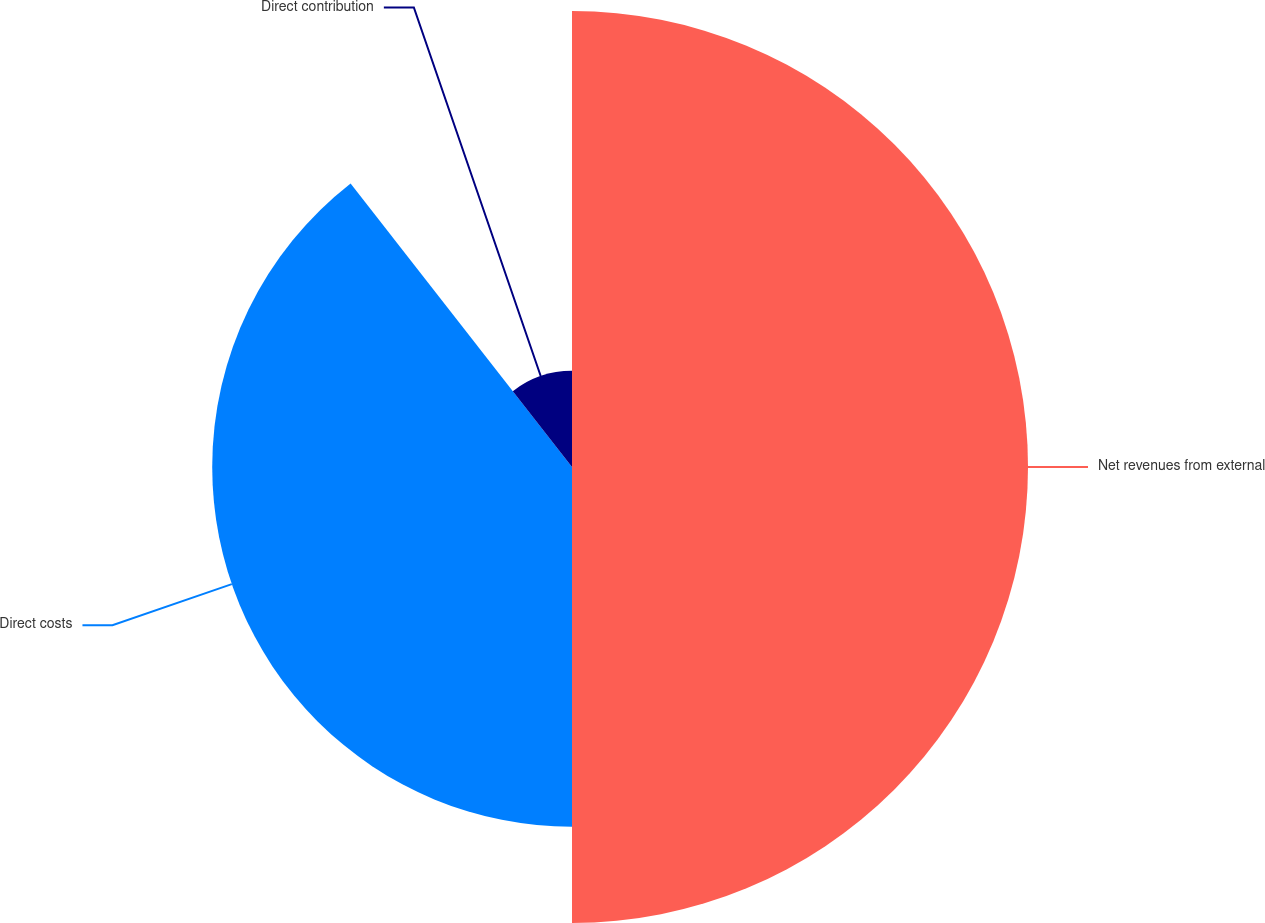<chart> <loc_0><loc_0><loc_500><loc_500><pie_chart><fcel>Net revenues from external<fcel>Direct costs<fcel>Direct contribution<nl><fcel>50.0%<fcel>39.45%<fcel>10.55%<nl></chart> 